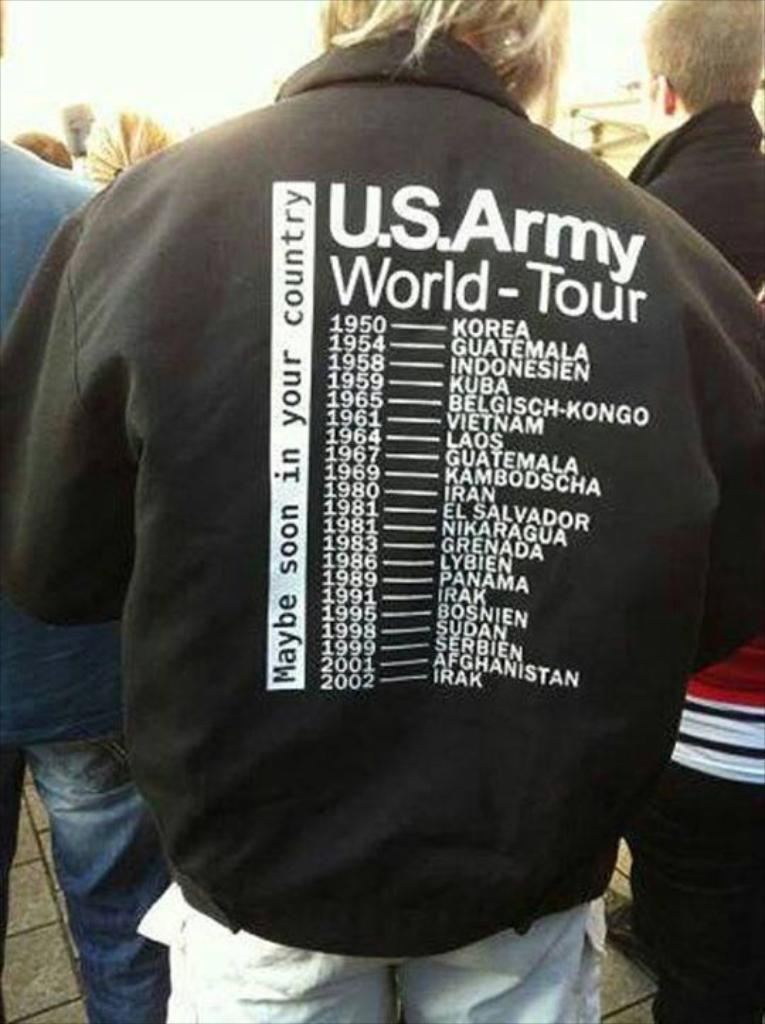How many people are in the image? There are people in the image, but the exact number is not specified. Can you describe the clothing of one of the people in the image? Yes, a man in the front is wearing a black color jacket. What can be seen at the top of the image? The sky is visible at the top of the image. What type of fuel is being used by the bears in the image? There are no bears present in the image, so it is not possible to determine what type of fuel they might be using. 